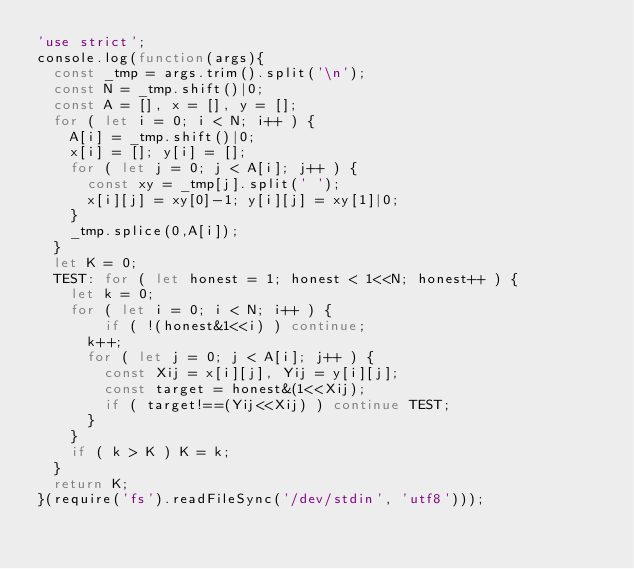<code> <loc_0><loc_0><loc_500><loc_500><_JavaScript_>'use strict';
console.log(function(args){
  const _tmp = args.trim().split('\n');
  const N = _tmp.shift()|0;
  const A = [], x = [], y = [];
  for ( let i = 0; i < N; i++ ) {
    A[i] = _tmp.shift()|0;
    x[i] = []; y[i] = [];
    for ( let j = 0; j < A[i]; j++ ) {
      const xy = _tmp[j].split(' ');
      x[i][j] = xy[0]-1; y[i][j] = xy[1]|0;
    }
    _tmp.splice(0,A[i]);
  }
  let K = 0;
  TEST: for ( let honest = 1; honest < 1<<N; honest++ ) {
    let k = 0;
    for ( let i = 0; i < N; i++ ) {
        if ( !(honest&1<<i) ) continue;
      k++;
      for ( let j = 0; j < A[i]; j++ ) {
        const Xij = x[i][j], Yij = y[i][j];
        const target = honest&(1<<Xij);
        if ( target!==(Yij<<Xij) ) continue TEST;
      }
    }
    if ( k > K ) K = k;
  }
  return K;
}(require('fs').readFileSync('/dev/stdin', 'utf8')));
</code> 